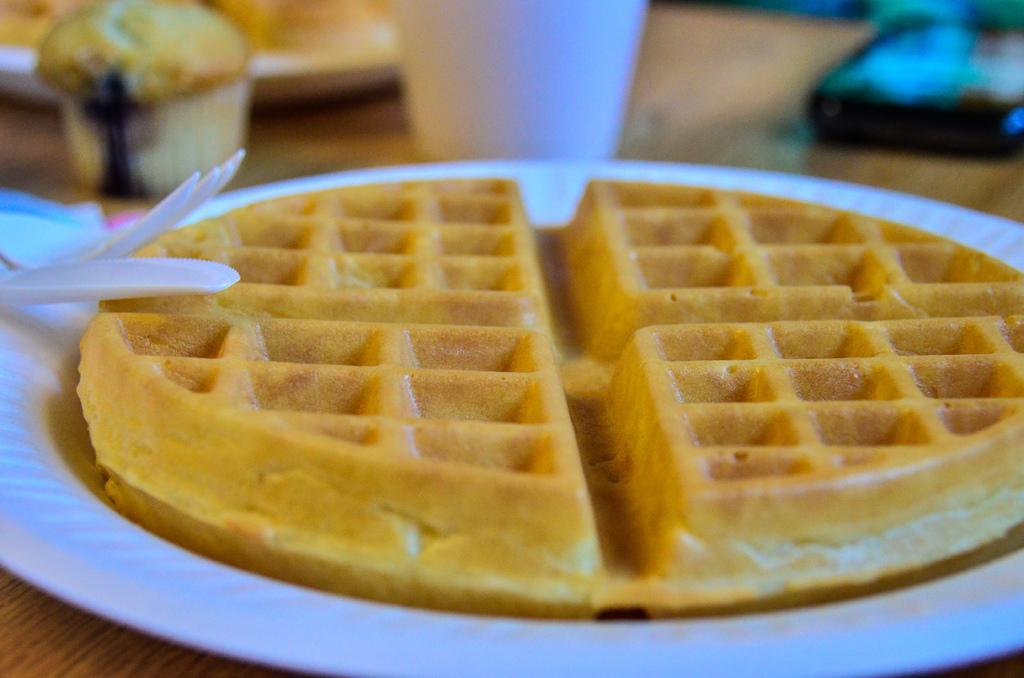Could you give a brief overview of what you see in this image? In this picture there is food on the plate. There are plates and there is a bowl, glass, device, fork and spoon on the table. 